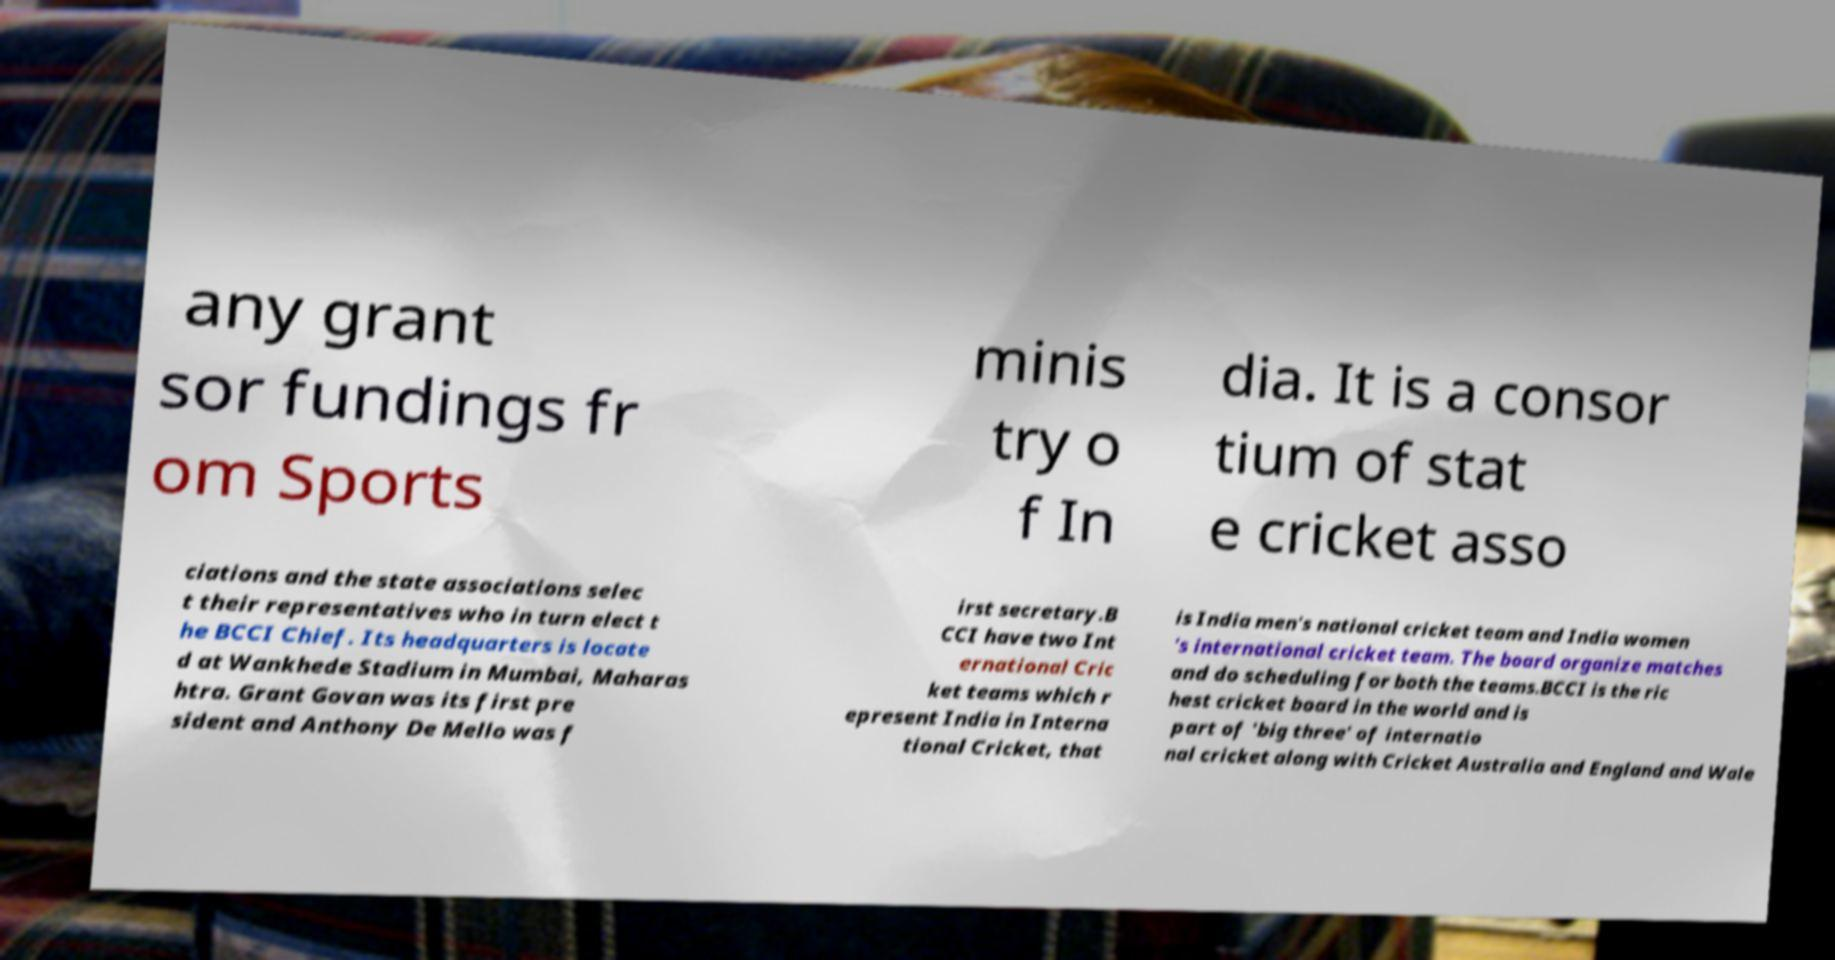Can you accurately transcribe the text from the provided image for me? any grant sor fundings fr om Sports minis try o f In dia. It is a consor tium of stat e cricket asso ciations and the state associations selec t their representatives who in turn elect t he BCCI Chief. Its headquarters is locate d at Wankhede Stadium in Mumbai, Maharas htra. Grant Govan was its first pre sident and Anthony De Mello was f irst secretary.B CCI have two Int ernational Cric ket teams which r epresent India in Interna tional Cricket, that is India men's national cricket team and India women 's international cricket team. The board organize matches and do scheduling for both the teams.BCCI is the ric hest cricket board in the world and is part of 'big three' of internatio nal cricket along with Cricket Australia and England and Wale 